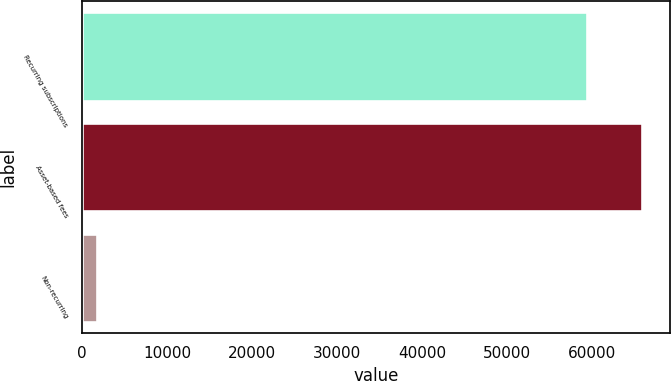<chart> <loc_0><loc_0><loc_500><loc_500><bar_chart><fcel>Recurring subscriptions<fcel>Asset-based fees<fcel>Non-recurring<nl><fcel>59354<fcel>65863<fcel>1714<nl></chart> 